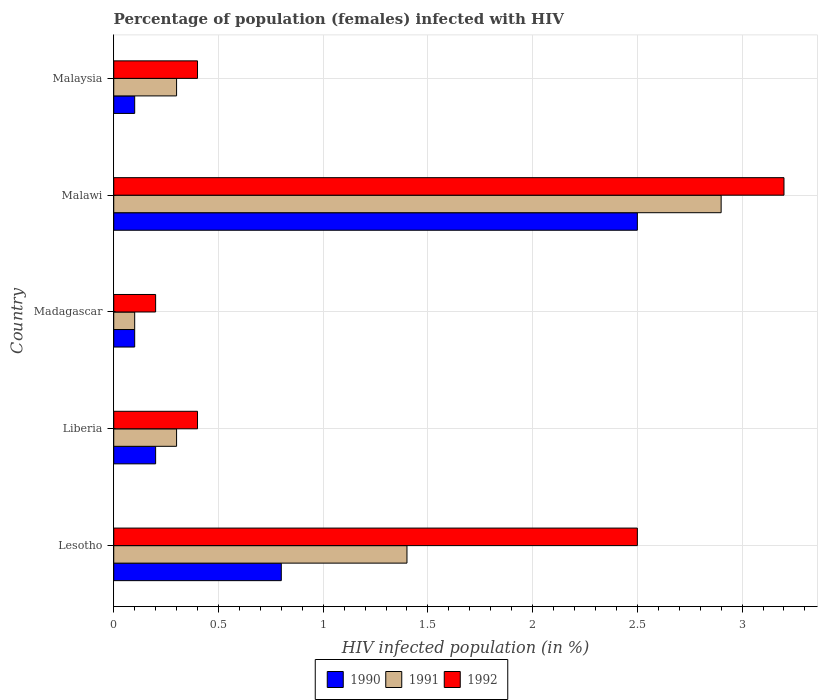How many different coloured bars are there?
Provide a succinct answer. 3. Are the number of bars per tick equal to the number of legend labels?
Ensure brevity in your answer.  Yes. How many bars are there on the 2nd tick from the top?
Keep it short and to the point. 3. How many bars are there on the 5th tick from the bottom?
Your answer should be compact. 3. What is the label of the 5th group of bars from the top?
Provide a succinct answer. Lesotho. In which country was the percentage of HIV infected female population in 1992 maximum?
Give a very brief answer. Malawi. In which country was the percentage of HIV infected female population in 1990 minimum?
Provide a succinct answer. Madagascar. What is the total percentage of HIV infected female population in 1990 in the graph?
Your answer should be compact. 3.7. What is the difference between the percentage of HIV infected female population in 1992 in Lesotho and that in Malawi?
Provide a succinct answer. -0.7. What is the difference between the percentage of HIV infected female population in 1991 in Malawi and the percentage of HIV infected female population in 1992 in Malaysia?
Ensure brevity in your answer.  2.5. What is the average percentage of HIV infected female population in 1992 per country?
Keep it short and to the point. 1.34. What is the difference between the percentage of HIV infected female population in 1992 and percentage of HIV infected female population in 1991 in Malawi?
Give a very brief answer. 0.3. What is the ratio of the percentage of HIV infected female population in 1991 in Lesotho to that in Liberia?
Provide a short and direct response. 4.67. Is the percentage of HIV infected female population in 1990 in Lesotho less than that in Malawi?
Your answer should be compact. Yes. What is the difference between the highest and the second highest percentage of HIV infected female population in 1992?
Offer a very short reply. 0.7. What is the difference between the highest and the lowest percentage of HIV infected female population in 1990?
Ensure brevity in your answer.  2.4. What does the 3rd bar from the top in Madagascar represents?
Offer a terse response. 1990. How many bars are there?
Ensure brevity in your answer.  15. How many countries are there in the graph?
Your answer should be compact. 5. What is the difference between two consecutive major ticks on the X-axis?
Offer a terse response. 0.5. Are the values on the major ticks of X-axis written in scientific E-notation?
Offer a terse response. No. Where does the legend appear in the graph?
Give a very brief answer. Bottom center. How many legend labels are there?
Provide a succinct answer. 3. What is the title of the graph?
Your answer should be very brief. Percentage of population (females) infected with HIV. What is the label or title of the X-axis?
Make the answer very short. HIV infected population (in %). What is the label or title of the Y-axis?
Give a very brief answer. Country. What is the HIV infected population (in %) in 1991 in Lesotho?
Provide a short and direct response. 1.4. What is the HIV infected population (in %) of 1992 in Lesotho?
Offer a very short reply. 2.5. What is the HIV infected population (in %) in 1991 in Liberia?
Your answer should be very brief. 0.3. What is the HIV infected population (in %) in 1990 in Madagascar?
Provide a short and direct response. 0.1. What is the HIV infected population (in %) in 1991 in Madagascar?
Ensure brevity in your answer.  0.1. What is the HIV infected population (in %) in 1991 in Malawi?
Provide a succinct answer. 2.9. What is the HIV infected population (in %) of 1990 in Malaysia?
Your answer should be very brief. 0.1. What is the HIV infected population (in %) in 1991 in Malaysia?
Your response must be concise. 0.3. What is the HIV infected population (in %) in 1992 in Malaysia?
Offer a very short reply. 0.4. What is the total HIV infected population (in %) of 1991 in the graph?
Provide a short and direct response. 5. What is the difference between the HIV infected population (in %) in 1991 in Lesotho and that in Madagascar?
Offer a very short reply. 1.3. What is the difference between the HIV infected population (in %) in 1992 in Lesotho and that in Madagascar?
Your answer should be very brief. 2.3. What is the difference between the HIV infected population (in %) of 1991 in Lesotho and that in Malawi?
Your response must be concise. -1.5. What is the difference between the HIV infected population (in %) of 1992 in Lesotho and that in Malawi?
Offer a terse response. -0.7. What is the difference between the HIV infected population (in %) of 1990 in Lesotho and that in Malaysia?
Ensure brevity in your answer.  0.7. What is the difference between the HIV infected population (in %) in 1992 in Lesotho and that in Malaysia?
Your answer should be very brief. 2.1. What is the difference between the HIV infected population (in %) of 1990 in Liberia and that in Madagascar?
Keep it short and to the point. 0.1. What is the difference between the HIV infected population (in %) in 1991 in Liberia and that in Madagascar?
Ensure brevity in your answer.  0.2. What is the difference between the HIV infected population (in %) in 1992 in Liberia and that in Malaysia?
Your response must be concise. 0. What is the difference between the HIV infected population (in %) in 1990 in Madagascar and that in Malawi?
Keep it short and to the point. -2.4. What is the difference between the HIV infected population (in %) of 1991 in Madagascar and that in Malawi?
Your answer should be compact. -2.8. What is the difference between the HIV infected population (in %) of 1992 in Madagascar and that in Malawi?
Give a very brief answer. -3. What is the difference between the HIV infected population (in %) of 1990 in Madagascar and that in Malaysia?
Ensure brevity in your answer.  0. What is the difference between the HIV infected population (in %) in 1991 in Madagascar and that in Malaysia?
Your answer should be very brief. -0.2. What is the difference between the HIV infected population (in %) in 1992 in Madagascar and that in Malaysia?
Offer a terse response. -0.2. What is the difference between the HIV infected population (in %) of 1991 in Malawi and that in Malaysia?
Your answer should be very brief. 2.6. What is the difference between the HIV infected population (in %) of 1991 in Lesotho and the HIV infected population (in %) of 1992 in Madagascar?
Give a very brief answer. 1.2. What is the difference between the HIV infected population (in %) in 1990 in Lesotho and the HIV infected population (in %) in 1992 in Malawi?
Keep it short and to the point. -2.4. What is the difference between the HIV infected population (in %) in 1990 in Lesotho and the HIV infected population (in %) in 1991 in Malaysia?
Your answer should be compact. 0.5. What is the difference between the HIV infected population (in %) of 1990 in Lesotho and the HIV infected population (in %) of 1992 in Malaysia?
Ensure brevity in your answer.  0.4. What is the difference between the HIV infected population (in %) of 1990 in Liberia and the HIV infected population (in %) of 1992 in Madagascar?
Keep it short and to the point. 0. What is the difference between the HIV infected population (in %) of 1990 in Liberia and the HIV infected population (in %) of 1991 in Malawi?
Offer a terse response. -2.7. What is the difference between the HIV infected population (in %) of 1991 in Liberia and the HIV infected population (in %) of 1992 in Malawi?
Make the answer very short. -2.9. What is the difference between the HIV infected population (in %) of 1990 in Liberia and the HIV infected population (in %) of 1991 in Malaysia?
Your answer should be very brief. -0.1. What is the difference between the HIV infected population (in %) in 1990 in Liberia and the HIV infected population (in %) in 1992 in Malaysia?
Your answer should be compact. -0.2. What is the difference between the HIV infected population (in %) of 1991 in Liberia and the HIV infected population (in %) of 1992 in Malaysia?
Keep it short and to the point. -0.1. What is the difference between the HIV infected population (in %) of 1990 in Madagascar and the HIV infected population (in %) of 1992 in Malawi?
Offer a terse response. -3.1. What is the difference between the HIV infected population (in %) in 1990 in Malawi and the HIV infected population (in %) in 1991 in Malaysia?
Give a very brief answer. 2.2. What is the difference between the HIV infected population (in %) in 1990 in Malawi and the HIV infected population (in %) in 1992 in Malaysia?
Provide a succinct answer. 2.1. What is the difference between the HIV infected population (in %) in 1991 in Malawi and the HIV infected population (in %) in 1992 in Malaysia?
Make the answer very short. 2.5. What is the average HIV infected population (in %) in 1990 per country?
Provide a short and direct response. 0.74. What is the average HIV infected population (in %) in 1991 per country?
Your answer should be compact. 1. What is the average HIV infected population (in %) of 1992 per country?
Make the answer very short. 1.34. What is the difference between the HIV infected population (in %) of 1990 and HIV infected population (in %) of 1991 in Lesotho?
Your answer should be compact. -0.6. What is the difference between the HIV infected population (in %) in 1990 and HIV infected population (in %) in 1992 in Lesotho?
Your response must be concise. -1.7. What is the difference between the HIV infected population (in %) in 1991 and HIV infected population (in %) in 1992 in Lesotho?
Provide a succinct answer. -1.1. What is the difference between the HIV infected population (in %) in 1990 and HIV infected population (in %) in 1991 in Liberia?
Give a very brief answer. -0.1. What is the difference between the HIV infected population (in %) of 1990 and HIV infected population (in %) of 1992 in Liberia?
Provide a short and direct response. -0.2. What is the difference between the HIV infected population (in %) of 1990 and HIV infected population (in %) of 1992 in Madagascar?
Your answer should be compact. -0.1. What is the difference between the HIV infected population (in %) of 1990 and HIV infected population (in %) of 1991 in Malawi?
Provide a succinct answer. -0.4. What is the difference between the HIV infected population (in %) of 1991 and HIV infected population (in %) of 1992 in Malawi?
Give a very brief answer. -0.3. What is the difference between the HIV infected population (in %) of 1990 and HIV infected population (in %) of 1992 in Malaysia?
Give a very brief answer. -0.3. What is the ratio of the HIV infected population (in %) in 1990 in Lesotho to that in Liberia?
Give a very brief answer. 4. What is the ratio of the HIV infected population (in %) of 1991 in Lesotho to that in Liberia?
Ensure brevity in your answer.  4.67. What is the ratio of the HIV infected population (in %) of 1992 in Lesotho to that in Liberia?
Offer a very short reply. 6.25. What is the ratio of the HIV infected population (in %) of 1990 in Lesotho to that in Malawi?
Your answer should be compact. 0.32. What is the ratio of the HIV infected population (in %) in 1991 in Lesotho to that in Malawi?
Give a very brief answer. 0.48. What is the ratio of the HIV infected population (in %) in 1992 in Lesotho to that in Malawi?
Your answer should be compact. 0.78. What is the ratio of the HIV infected population (in %) in 1990 in Lesotho to that in Malaysia?
Your answer should be compact. 8. What is the ratio of the HIV infected population (in %) in 1991 in Lesotho to that in Malaysia?
Offer a very short reply. 4.67. What is the ratio of the HIV infected population (in %) in 1992 in Lesotho to that in Malaysia?
Offer a very short reply. 6.25. What is the ratio of the HIV infected population (in %) of 1990 in Liberia to that in Madagascar?
Provide a succinct answer. 2. What is the ratio of the HIV infected population (in %) in 1991 in Liberia to that in Madagascar?
Your answer should be compact. 3. What is the ratio of the HIV infected population (in %) in 1990 in Liberia to that in Malawi?
Ensure brevity in your answer.  0.08. What is the ratio of the HIV infected population (in %) in 1991 in Liberia to that in Malawi?
Provide a succinct answer. 0.1. What is the ratio of the HIV infected population (in %) in 1990 in Liberia to that in Malaysia?
Your answer should be very brief. 2. What is the ratio of the HIV infected population (in %) of 1992 in Liberia to that in Malaysia?
Give a very brief answer. 1. What is the ratio of the HIV infected population (in %) in 1990 in Madagascar to that in Malawi?
Give a very brief answer. 0.04. What is the ratio of the HIV infected population (in %) of 1991 in Madagascar to that in Malawi?
Ensure brevity in your answer.  0.03. What is the ratio of the HIV infected population (in %) of 1992 in Madagascar to that in Malawi?
Keep it short and to the point. 0.06. What is the ratio of the HIV infected population (in %) in 1991 in Madagascar to that in Malaysia?
Ensure brevity in your answer.  0.33. What is the ratio of the HIV infected population (in %) of 1992 in Madagascar to that in Malaysia?
Provide a succinct answer. 0.5. What is the ratio of the HIV infected population (in %) of 1991 in Malawi to that in Malaysia?
Offer a terse response. 9.67. What is the ratio of the HIV infected population (in %) in 1992 in Malawi to that in Malaysia?
Your answer should be compact. 8. What is the difference between the highest and the second highest HIV infected population (in %) in 1991?
Make the answer very short. 1.5. What is the difference between the highest and the second highest HIV infected population (in %) of 1992?
Offer a very short reply. 0.7. What is the difference between the highest and the lowest HIV infected population (in %) of 1990?
Offer a very short reply. 2.4. What is the difference between the highest and the lowest HIV infected population (in %) in 1991?
Ensure brevity in your answer.  2.8. What is the difference between the highest and the lowest HIV infected population (in %) of 1992?
Your answer should be very brief. 3. 